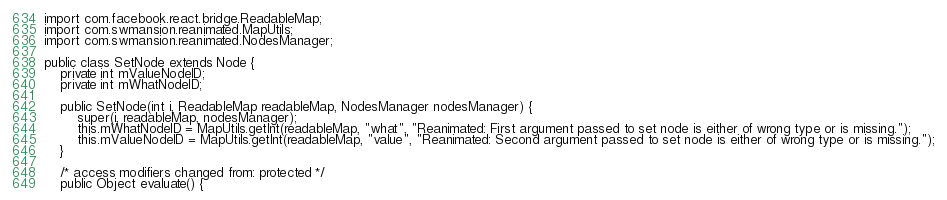<code> <loc_0><loc_0><loc_500><loc_500><_Java_>
import com.facebook.react.bridge.ReadableMap;
import com.swmansion.reanimated.MapUtils;
import com.swmansion.reanimated.NodesManager;

public class SetNode extends Node {
    private int mValueNodeID;
    private int mWhatNodeID;

    public SetNode(int i, ReadableMap readableMap, NodesManager nodesManager) {
        super(i, readableMap, nodesManager);
        this.mWhatNodeID = MapUtils.getInt(readableMap, "what", "Reanimated: First argument passed to set node is either of wrong type or is missing.");
        this.mValueNodeID = MapUtils.getInt(readableMap, "value", "Reanimated: Second argument passed to set node is either of wrong type or is missing.");
    }

    /* access modifiers changed from: protected */
    public Object evaluate() {</code> 